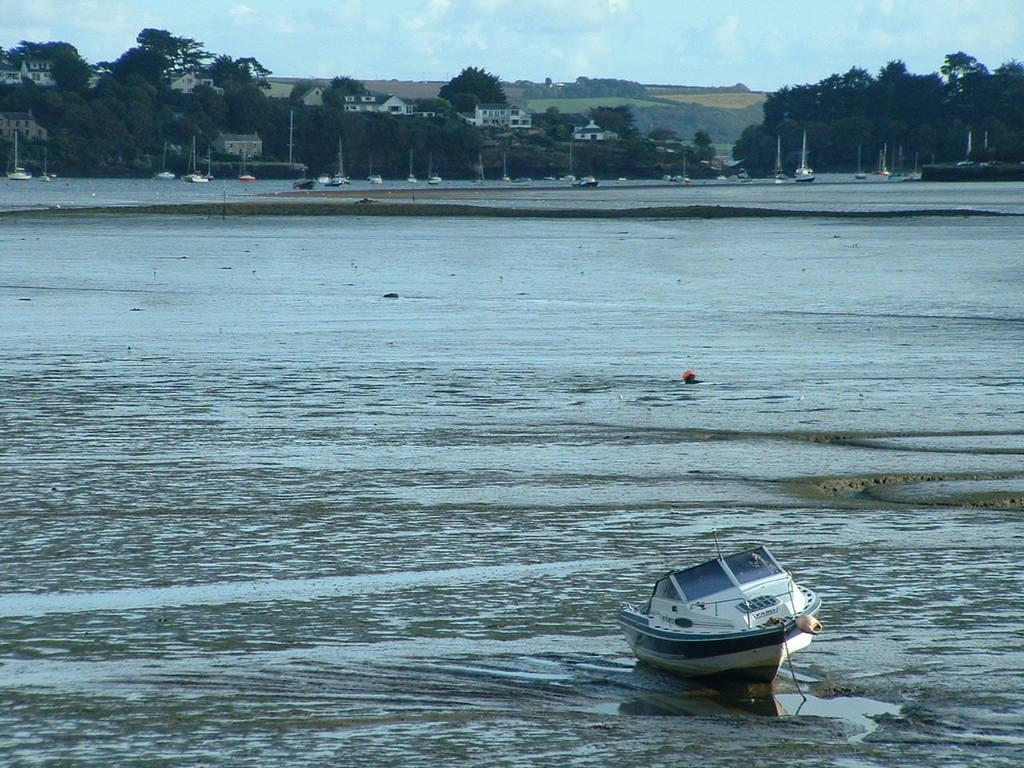Can you describe this image briefly? In the picture we can see water surface on it we can see a boat which is white in color with windshield to it and far away from it we can see many boats with poles on it and behind it we can see trees, plants and houses and in the background we can see the sky with clouds. 